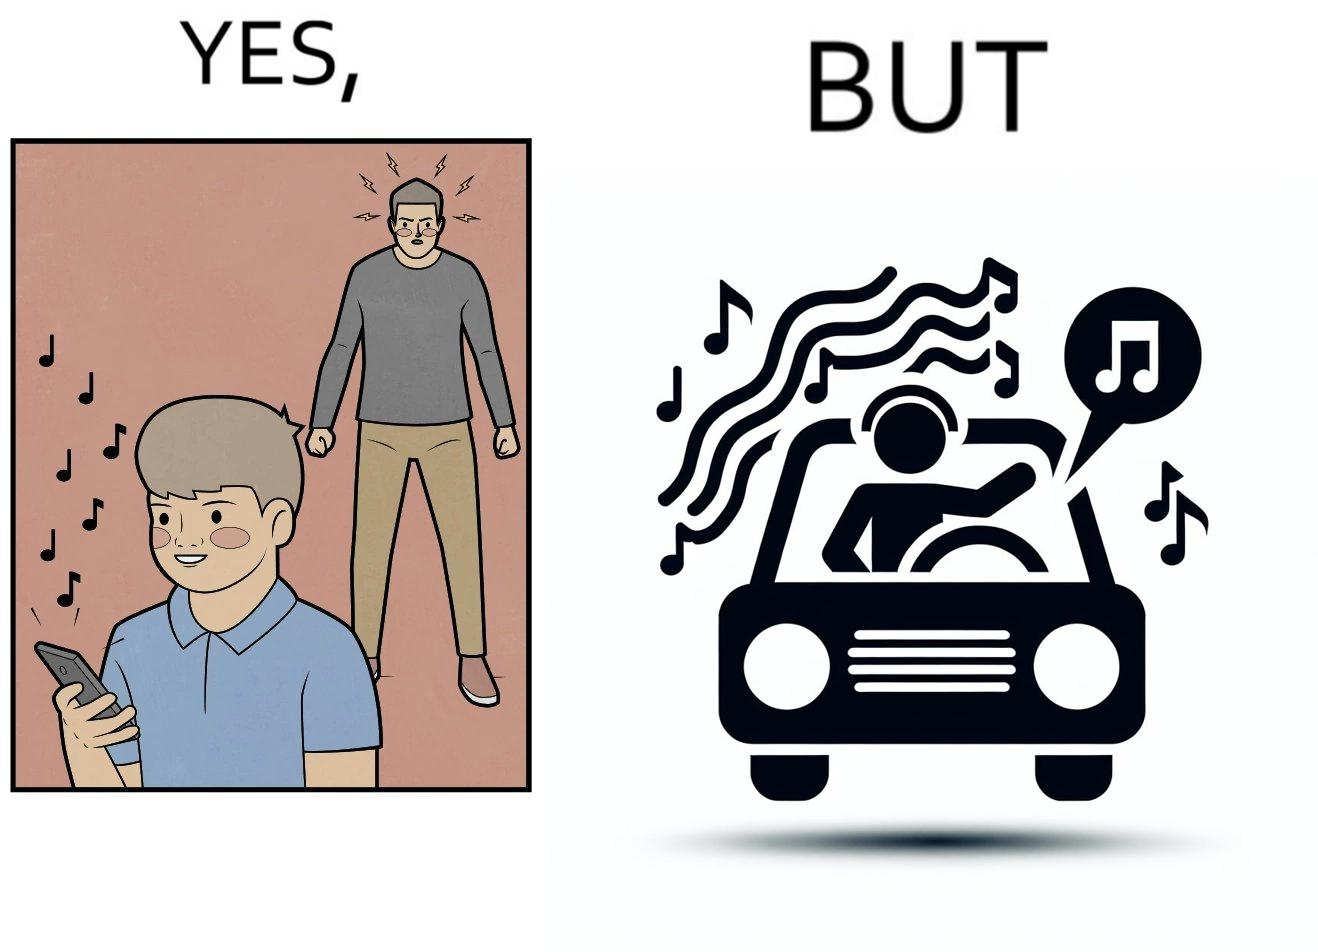Describe what you see in the left and right parts of this image. In the left part of the image: The image shows a boy playing music on his phone loudly. The image also shows another man annoyed by the loud music. In the right part of the image: The image shows a man driving a car with the windows of the car rolled down. He has one of his hands on the steering wheel and the other hand hanging out of the window of the driver side of the car. The man is playing loud music in his car with the sound coming out of the car. 